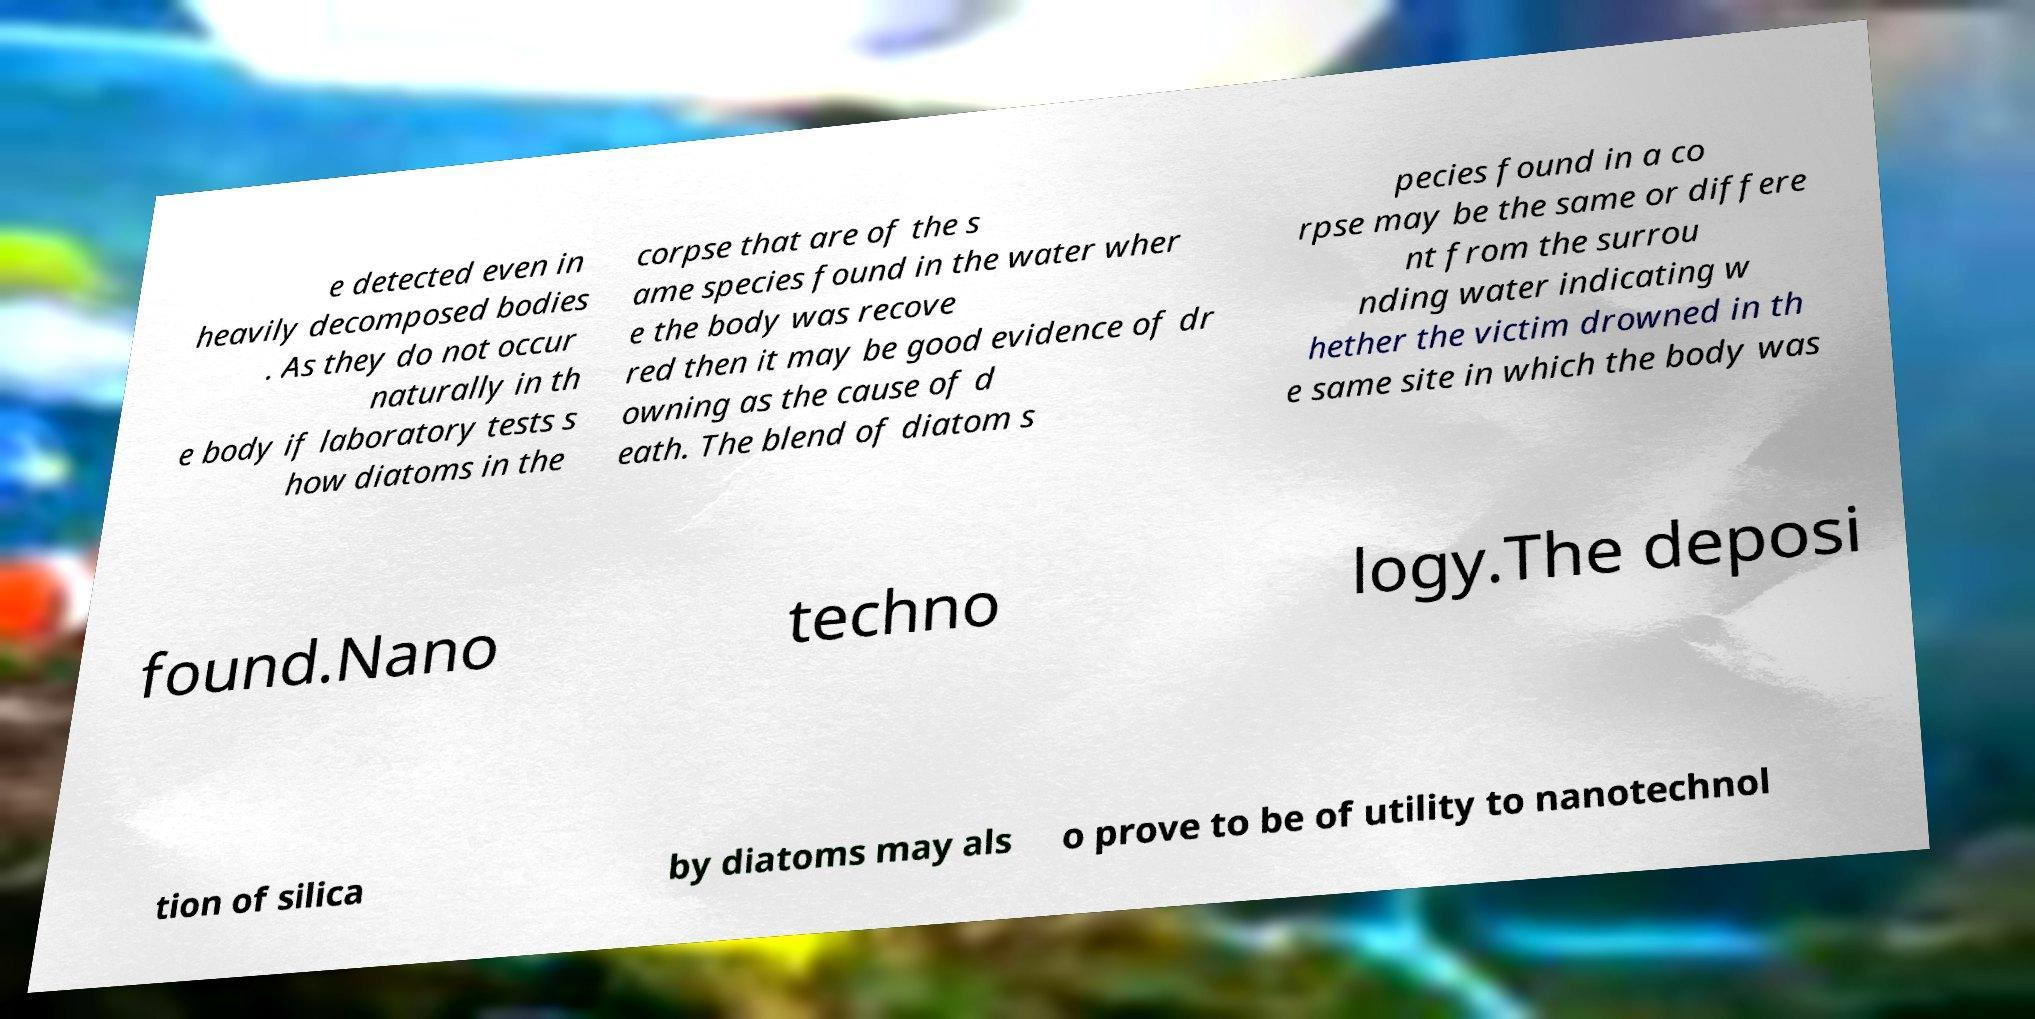Please read and relay the text visible in this image. What does it say? e detected even in heavily decomposed bodies . As they do not occur naturally in th e body if laboratory tests s how diatoms in the corpse that are of the s ame species found in the water wher e the body was recove red then it may be good evidence of dr owning as the cause of d eath. The blend of diatom s pecies found in a co rpse may be the same or differe nt from the surrou nding water indicating w hether the victim drowned in th e same site in which the body was found.Nano techno logy.The deposi tion of silica by diatoms may als o prove to be of utility to nanotechnol 